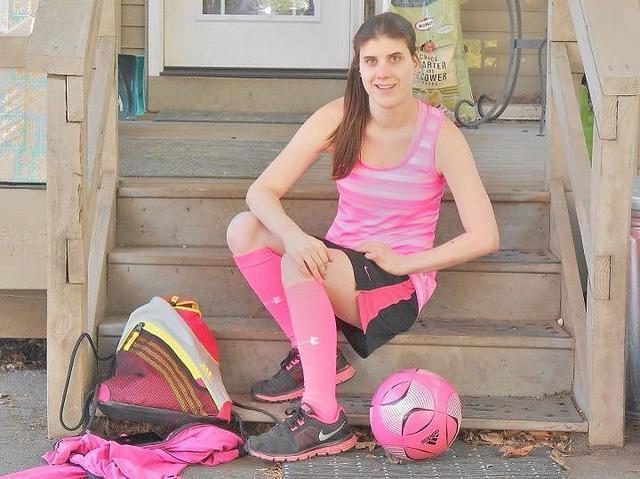How many dogs are in the room?
Give a very brief answer. 0. 